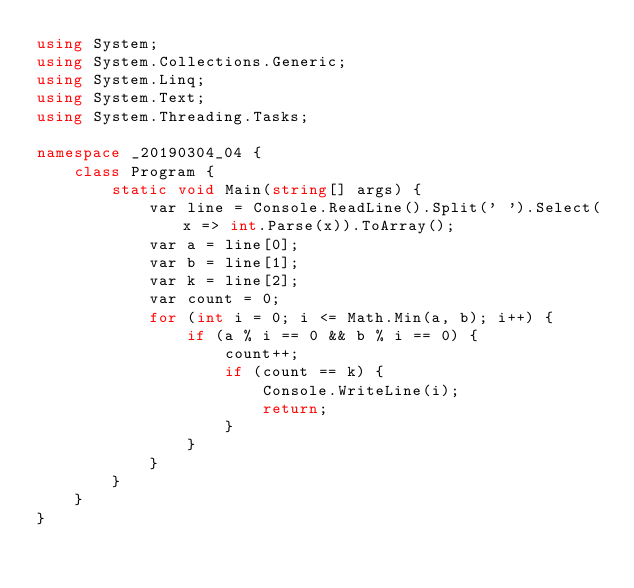Convert code to text. <code><loc_0><loc_0><loc_500><loc_500><_C#_>using System;
using System.Collections.Generic;
using System.Linq;
using System.Text;
using System.Threading.Tasks;

namespace _20190304_04 {
    class Program {
        static void Main(string[] args) {
            var line = Console.ReadLine().Split(' ').Select(x => int.Parse(x)).ToArray();
            var a = line[0];
            var b = line[1];
            var k = line[2];
            var count = 0;
            for (int i = 0; i <= Math.Min(a, b); i++) {
                if (a % i == 0 && b % i == 0) {
                    count++;
                    if (count == k) {
                        Console.WriteLine(i);
                        return;
                    }
                }
            }
        }
    }
}
</code> 